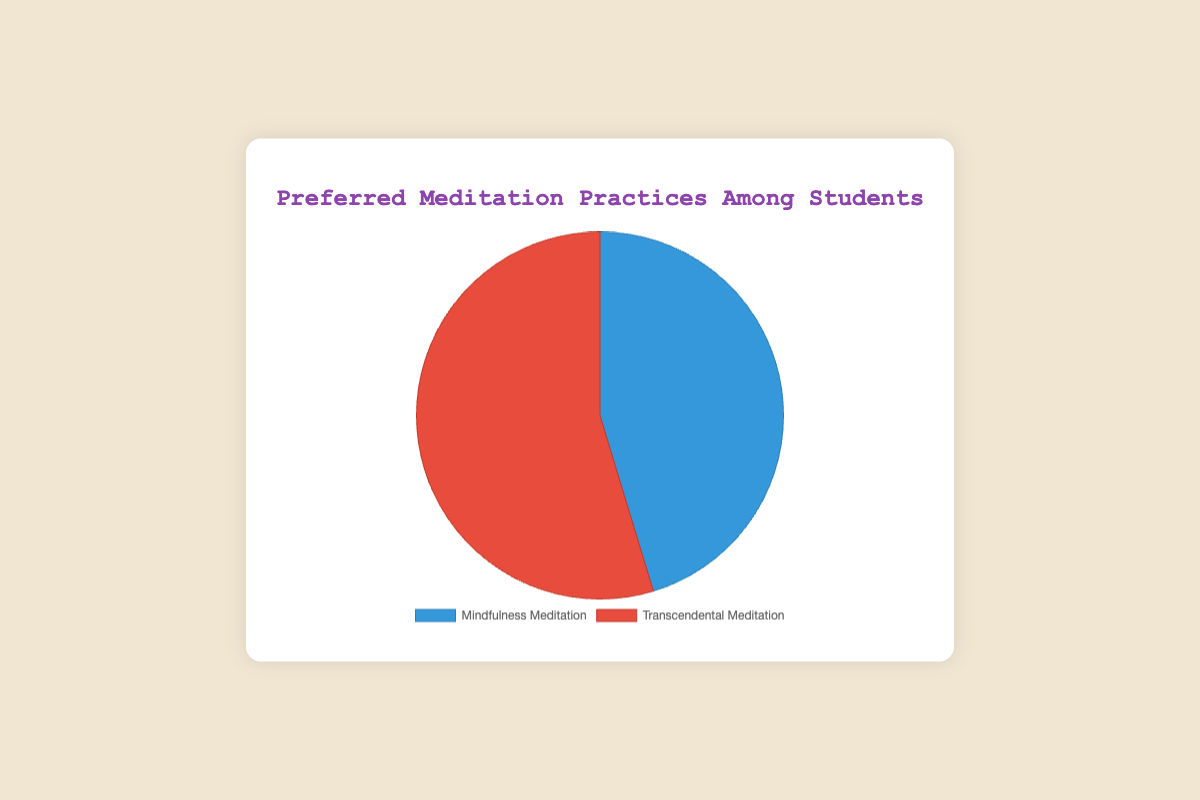What are the percentages of students preferring Mindfulness Meditation and Transcendental Meditation? The visualized pie chart shows the percentages directly. Mindfulness Meditation is represented with 45.3% of the chart, whereas Transcendental Meditation has 54.7%.
Answer: 45.3% for Mindfulness Meditation and 54.7% for Transcendental Meditation Which meditation practice is more popular among students? By comparing the two percentages in the pie chart, we see that Transcendental Meditation has a higher percentage (54.7%) than Mindfulness Meditation (45.3%).
Answer: Transcendental Meditation What is the difference in percentage between the two meditation practices? Subtract the percentage of Mindfulness Meditation from Transcendental Meditation: 54.7% - 45.3% = 9.4%.
Answer: 9.4% What color represents Transcendental Meditation in the chart? The visual attributes of the pie chart show that Transcendental Meditation is represented by the red section.
Answer: Red What is the sum of the percentages of Mindfulness and Transcendental Meditation? Add the two percentages shown in the pie chart: 45.3% + 54.7% = 100%.
Answer: 100% If you were to rank the meditation practices based on popularity, which comes first and by how much does it lead? Rank based on the percentages: Transcendental Meditation (54.7%) is first, leading by 54.7% - 45.3% = 9.4%.
Answer: Transcendental Meditation leads by 9.4% What proportion of the chart is filled with the section representing Mindfulness Meditation? The percentage given for Mindfulness Meditation is 45.3%, indicating that 45.3% of the chart is filled with this section.
Answer: 45.3% 